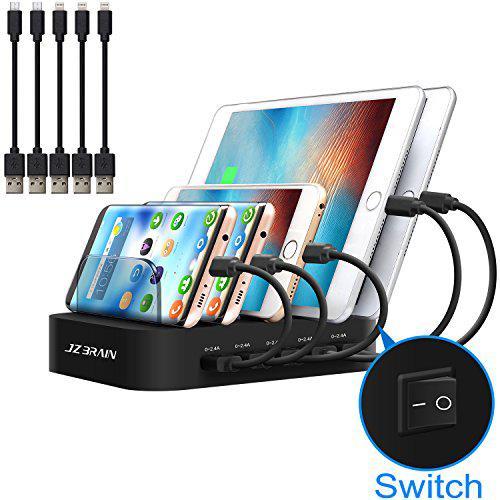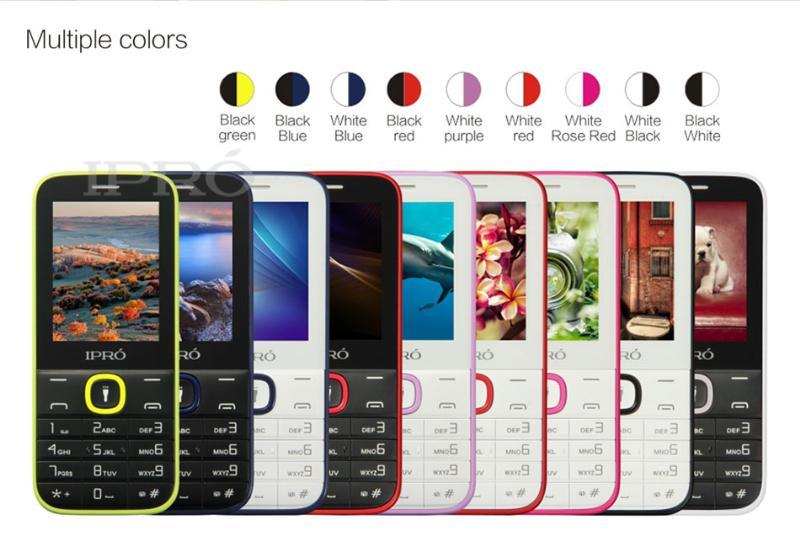The first image is the image on the left, the second image is the image on the right. Given the left and right images, does the statement "There is a non smart phone in a charger." hold true? Answer yes or no. No. The first image is the image on the left, the second image is the image on the right. For the images displayed, is the sentence "The right image contains no more than three cell phones." factually correct? Answer yes or no. No. 